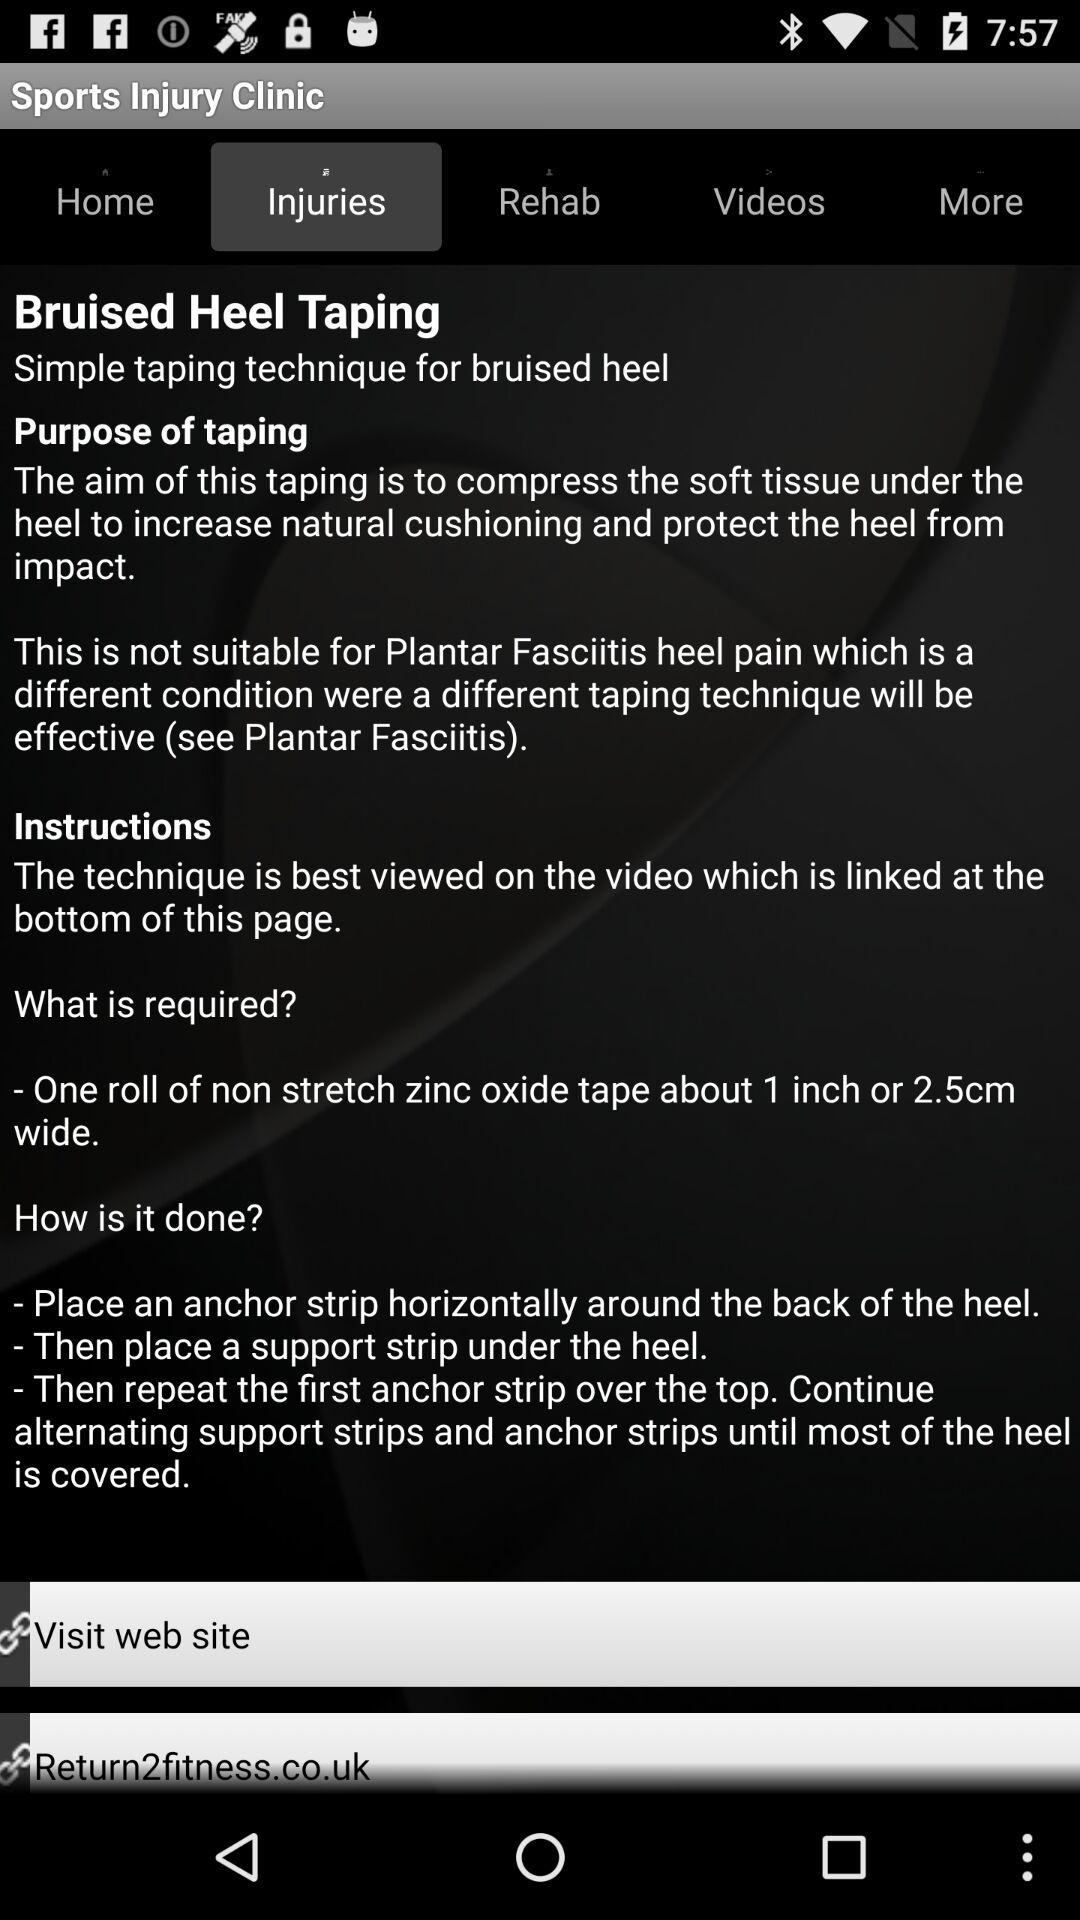What is the mail address displaying?
When the provided information is insufficient, respond with <no answer>. <no answer> 